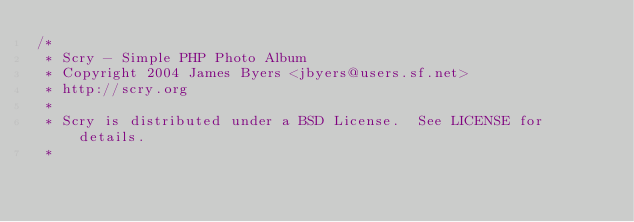<code> <loc_0><loc_0><loc_500><loc_500><_CSS_>/*
 * Scry - Simple PHP Photo Album
 * Copyright 2004 James Byers <jbyers@users.sf.net>
 * http://scry.org
 *
 * Scry is distributed under a BSD License.  See LICENSE for details.
 *</code> 